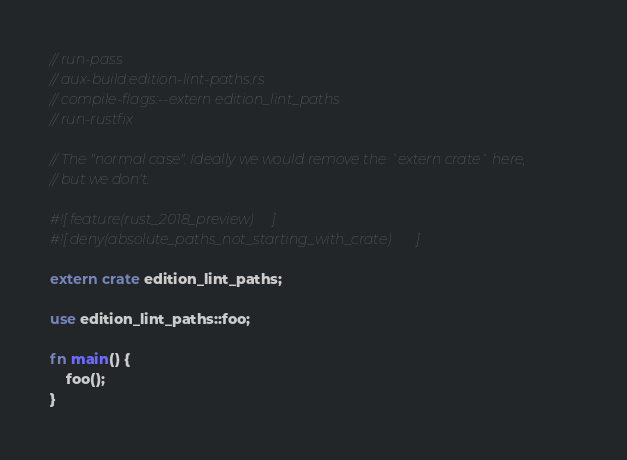Convert code to text. <code><loc_0><loc_0><loc_500><loc_500><_Rust_>// run-pass
// aux-build:edition-lint-paths.rs
// compile-flags:--extern edition_lint_paths
// run-rustfix

// The "normal case". Ideally we would remove the `extern crate` here,
// but we don't.

#![feature(rust_2018_preview)]
#![deny(absolute_paths_not_starting_with_crate)]

extern crate edition_lint_paths;

use edition_lint_paths::foo;

fn main() {
    foo();
}

</code> 